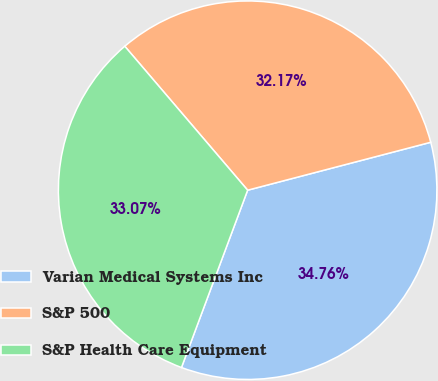Convert chart to OTSL. <chart><loc_0><loc_0><loc_500><loc_500><pie_chart><fcel>Varian Medical Systems Inc<fcel>S&P 500<fcel>S&P Health Care Equipment<nl><fcel>34.76%<fcel>32.17%<fcel>33.07%<nl></chart> 